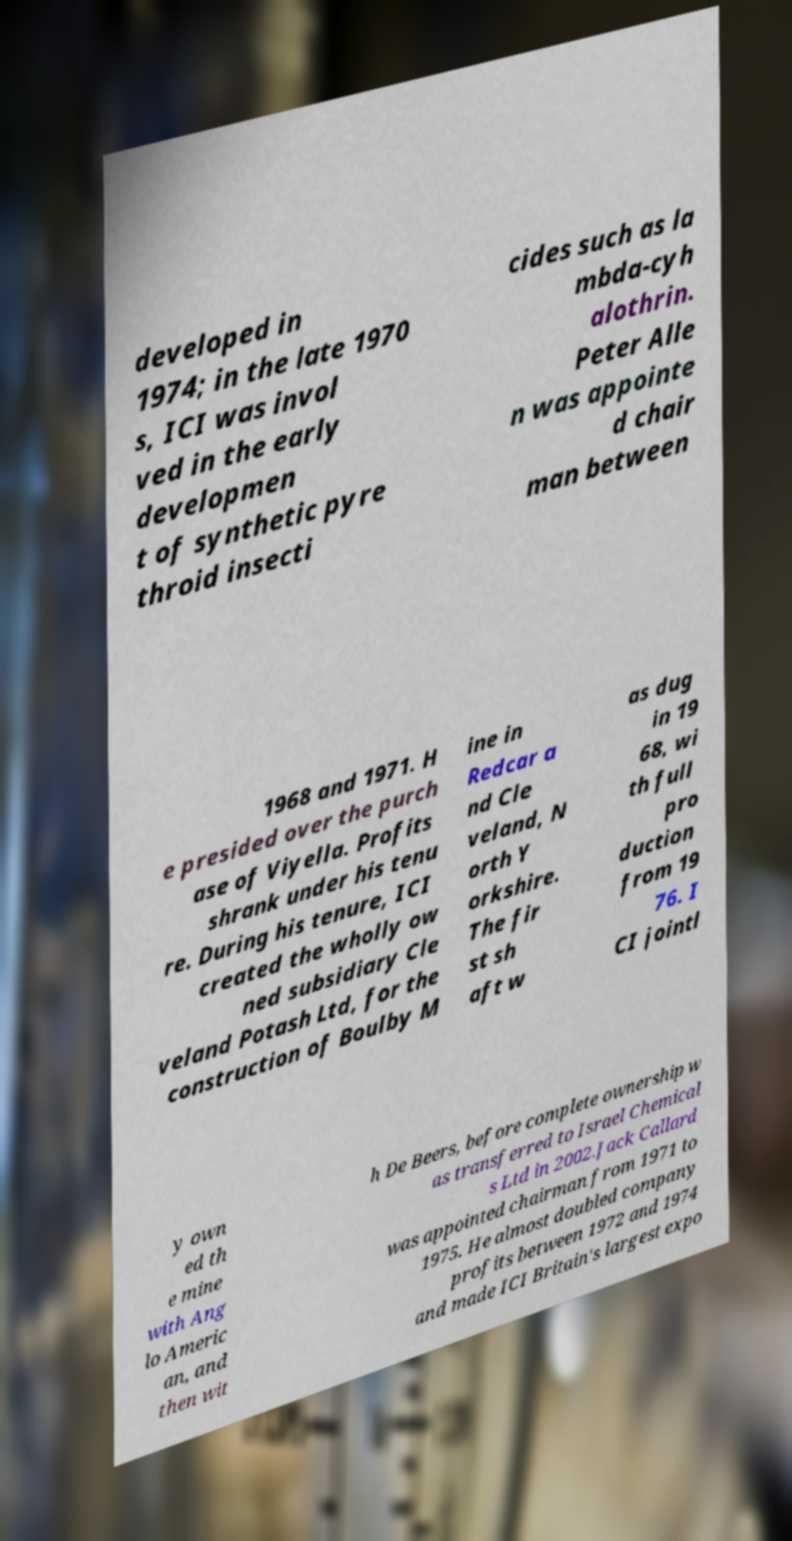Can you accurately transcribe the text from the provided image for me? developed in 1974; in the late 1970 s, ICI was invol ved in the early developmen t of synthetic pyre throid insecti cides such as la mbda-cyh alothrin. Peter Alle n was appointe d chair man between 1968 and 1971. H e presided over the purch ase of Viyella. Profits shrank under his tenu re. During his tenure, ICI created the wholly ow ned subsidiary Cle veland Potash Ltd, for the construction of Boulby M ine in Redcar a nd Cle veland, N orth Y orkshire. The fir st sh aft w as dug in 19 68, wi th full pro duction from 19 76. I CI jointl y own ed th e mine with Ang lo Americ an, and then wit h De Beers, before complete ownership w as transferred to Israel Chemical s Ltd in 2002.Jack Callard was appointed chairman from 1971 to 1975. He almost doubled company profits between 1972 and 1974 and made ICI Britain's largest expo 